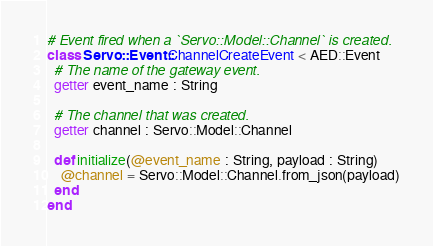<code> <loc_0><loc_0><loc_500><loc_500><_Crystal_># Event fired when a `Servo::Model::Channel` is created.
class Servo::Event::ChannelCreateEvent < AED::Event
  # The name of the gateway event.
  getter event_name : String

  # The channel that was created.
  getter channel : Servo::Model::Channel

  def initialize(@event_name : String, payload : String)
    @channel = Servo::Model::Channel.from_json(payload)
  end
end
</code> 